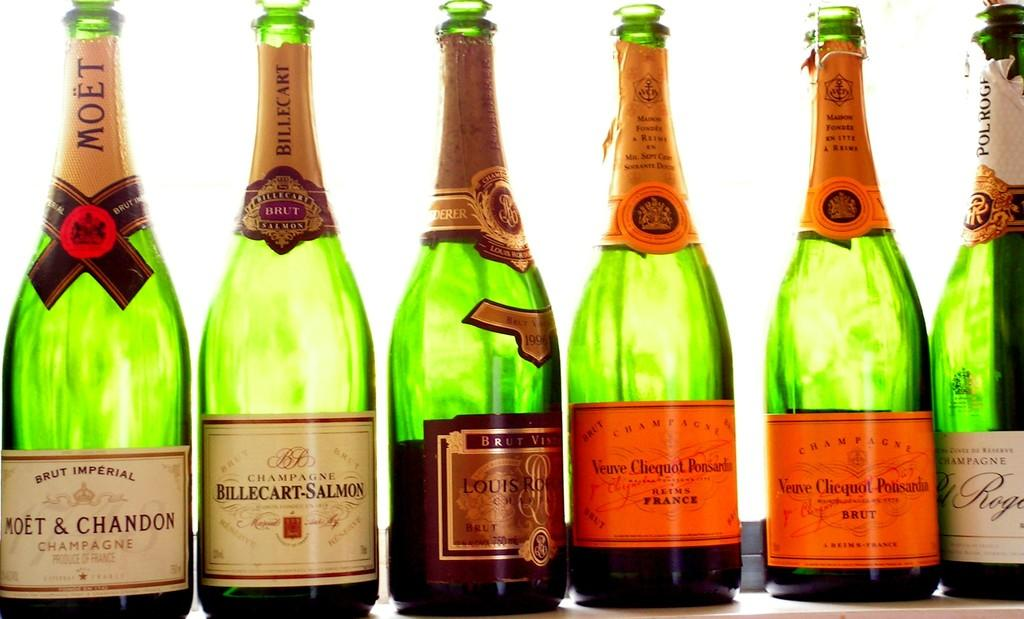<image>
Render a clear and concise summary of the photo. Six bottles of chmpagne with Moet & Chandon on the left. 